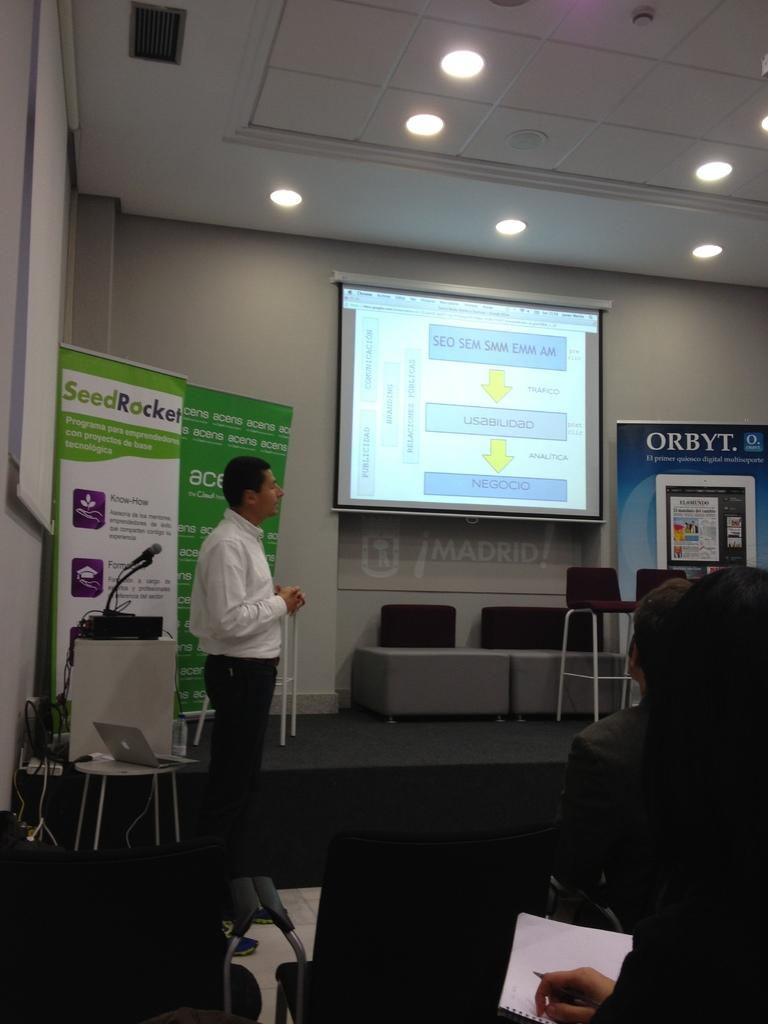Who is present in the image? There is a man in the image. What is the man doing in the image? The man is standing in the image. What can be seen behind the man in the image? There is a projector image behind the man. What type of illumination is visible in the image? There are lights visible in the image. What type of instrument is the man playing in the image? There is no instrument present in the image, and the man is not playing any instrument. 